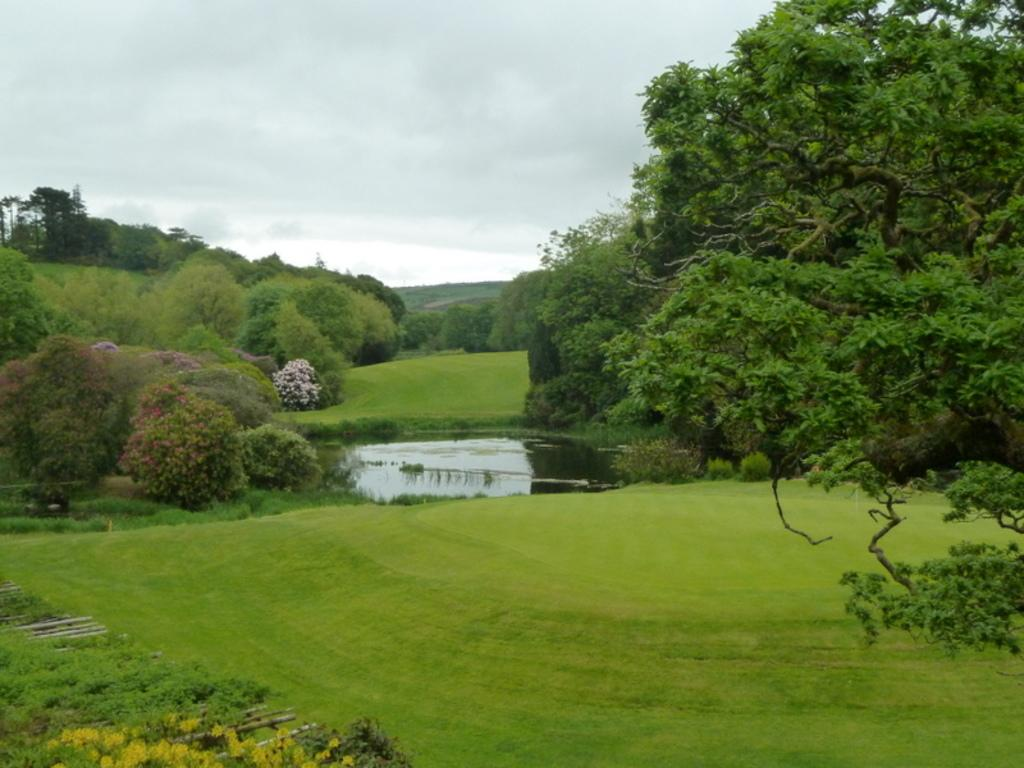What is the main feature in the center of the image? There is a pond in the center of the image. What can be seen in the background of the image? There are trees in the background of the image. What is visible at the top of the image? The sky is visible at the top of the image. What type of copper material can be seen in the image? There is no copper material present in the image. How do the ants navigate their way around the pond in the image? There are no ants present in the image, so their navigation cannot be observed. 